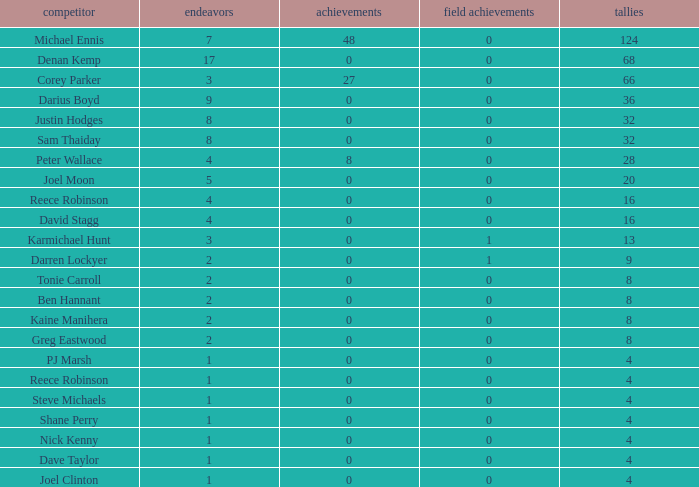What is the lowest tries the player with more than 0 goals, 28 points, and more than 0 field goals have? None. 